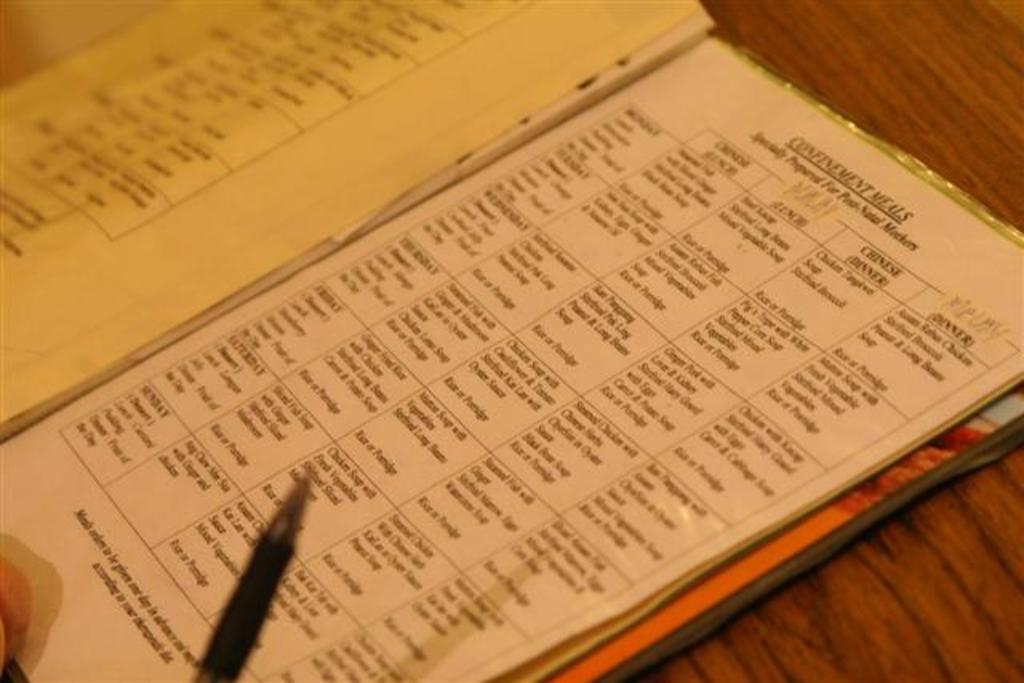<image>
Write a terse but informative summary of the picture. An open menu on a brown wooden table. 